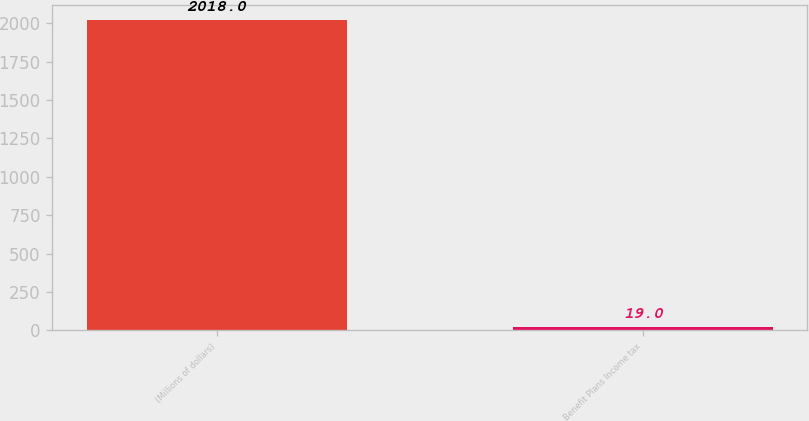Convert chart to OTSL. <chart><loc_0><loc_0><loc_500><loc_500><bar_chart><fcel>(Millions of dollars)<fcel>Benefit Plans Income tax<nl><fcel>2018<fcel>19<nl></chart> 